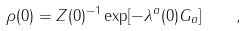<formula> <loc_0><loc_0><loc_500><loc_500>\rho ( 0 ) = Z ( 0 ) ^ { - 1 } \exp [ - \lambda ^ { a } ( 0 ) G _ { a } ] \quad ,</formula> 